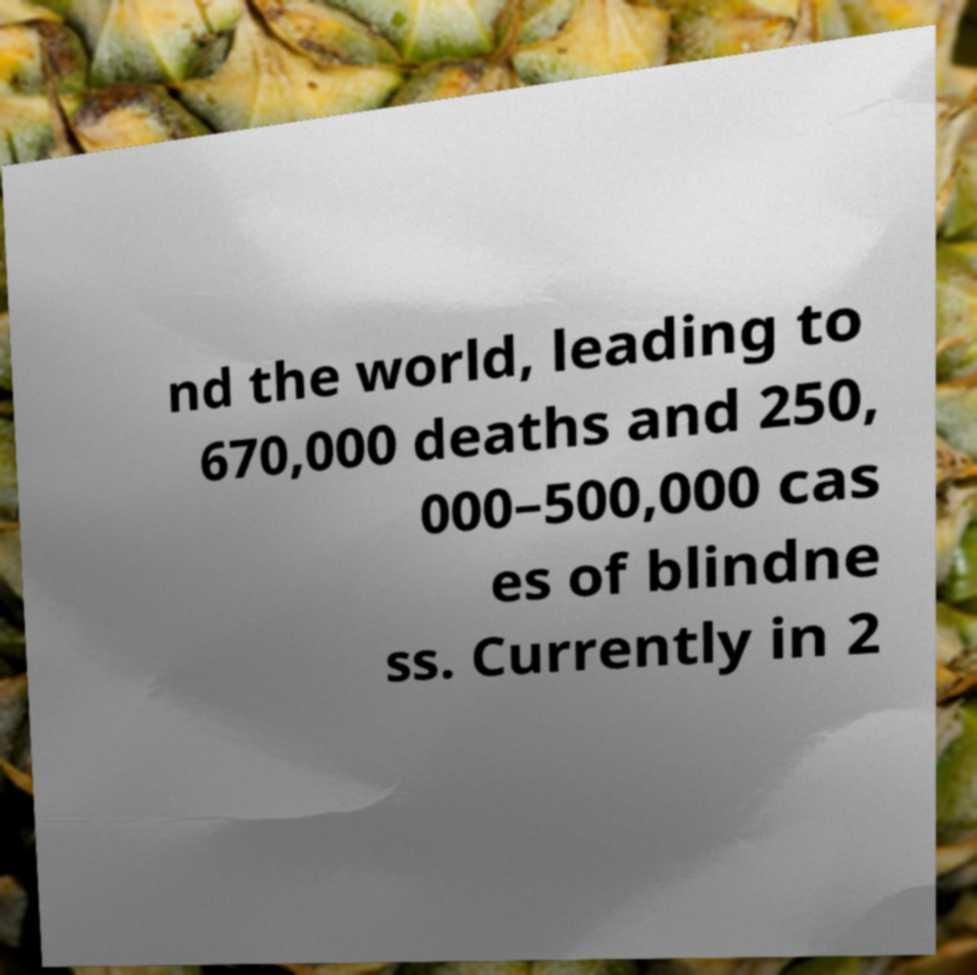Please read and relay the text visible in this image. What does it say? nd the world, leading to 670,000 deaths and 250, 000–500,000 cas es of blindne ss. Currently in 2 